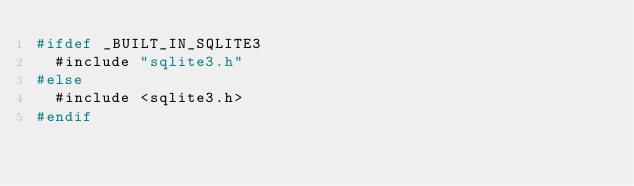<code> <loc_0><loc_0><loc_500><loc_500><_C_>#ifdef _BUILT_IN_SQLITE3
  #include "sqlite3.h"
#else
  #include <sqlite3.h>
#endif
</code> 